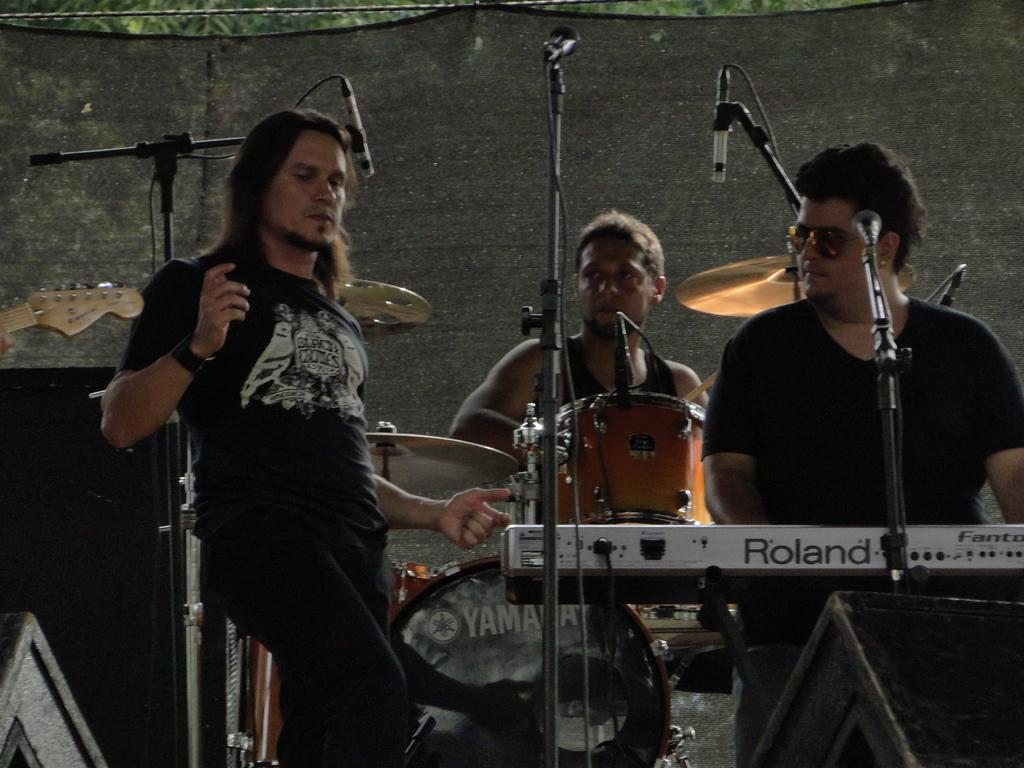How many men are present in the image? There are three men standing in the image. Can you describe the attire of the men? All three men are wearing black dress. Is there any specific accessory worn by one of the men? Yes, one of the men is wearing shades. What else can be seen in the image besides the men? There are mice and musical instruments in the image. How many visitors are present in the image? There is no mention of visitors in the image; it only features three men. What type of things are the mice using to play music in the image? There are no mice playing music in the image; the musical instruments are not associated with the mice. 